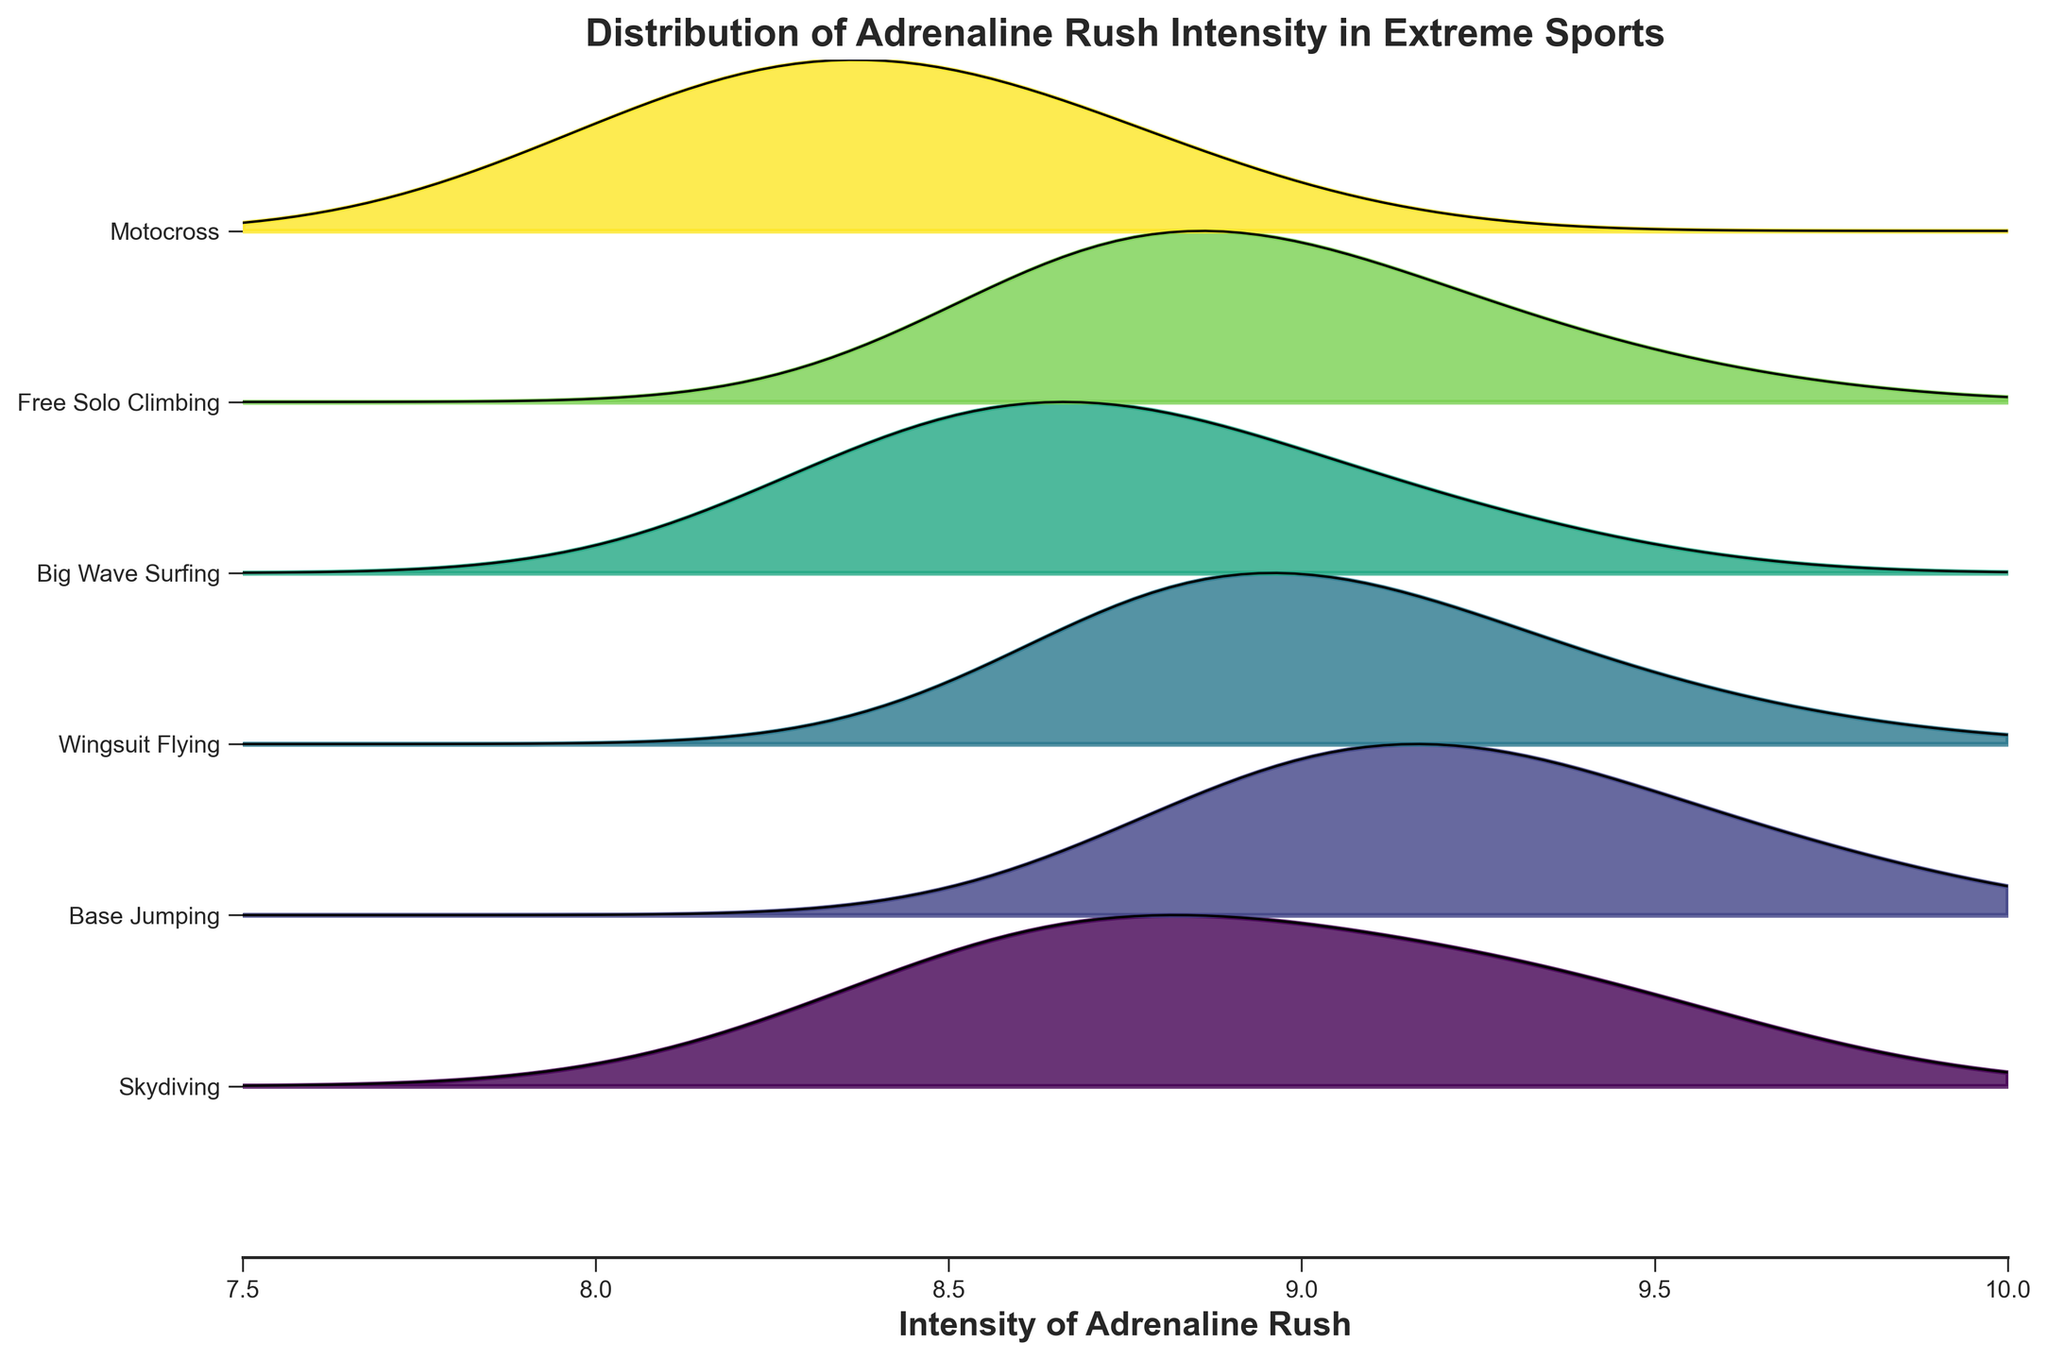What is the title of the plot? The title of the plot is located at the top of the figure and provides a summary of what the figure is about.
Answer: Distribution of Adrenaline Rush Intensity in Extreme Sports How many different activities are compared in the plot? The plot has labels on the y-axis for each activity being compared. Count these labels to determine the number of activities.
Answer: 6 Which activity has the highest maximum intensity of adrenaline rush according to the plot? Look at where the peaks of the distributions are positioned along the x-axis for each activity. The highest peak on the rightmost side indicates the highest intensity.
Answer: Base Jumping Which activity has the highest frequency of experiencing an adrenaline rush with an intensity of 8.7? Identify the activity that corresponds to the highest peak at the x-value of 8.7 on the plot. The y-value (height of the peak) determines the frequency.
Answer: Free Solo Climbing Which two activities have the same highest frequency or peak of adrenaline rushes? Locate activities that have peaks reaching the same height above the baseline on the y-axis. Compare the height of the peaks.
Answer: Free Solo Climbing and Big Wave Surfing What is the range of intensity values shown on the x-axis? The x-axis range can be determined by reading the minimum and maximum values displayed along the x-axis.
Answer: 7.5 to 10 Compare Skydiving and Motocross: Which one has a broader range of high-frequency adrenaline intensities? Examine the width of the peaks (frequency distribution) of each activity and compare which one spans a wider range of x-values (intensities).
Answer: Skydiving Which activity shows the least variation in the intensity of adrenaline rushes? Look for the distribution with the narrowest peak, as this indicates less variation in the intensity values.
Answer: Wingsuit Flying Is there an activity where the intensity of adrenaline rushes often falls below 8.5? Check the distributions to see if any have significant peaks to the left (below 8.5) on the x-axis.
Answer: Motocross 